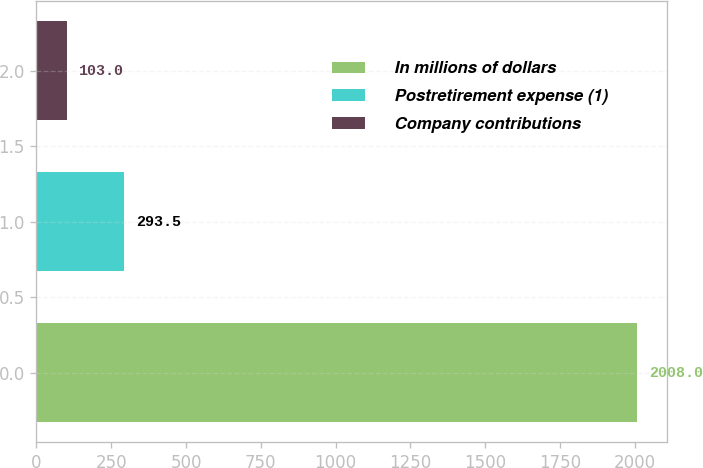Convert chart to OTSL. <chart><loc_0><loc_0><loc_500><loc_500><bar_chart><fcel>In millions of dollars<fcel>Postretirement expense (1)<fcel>Company contributions<nl><fcel>2008<fcel>293.5<fcel>103<nl></chart> 